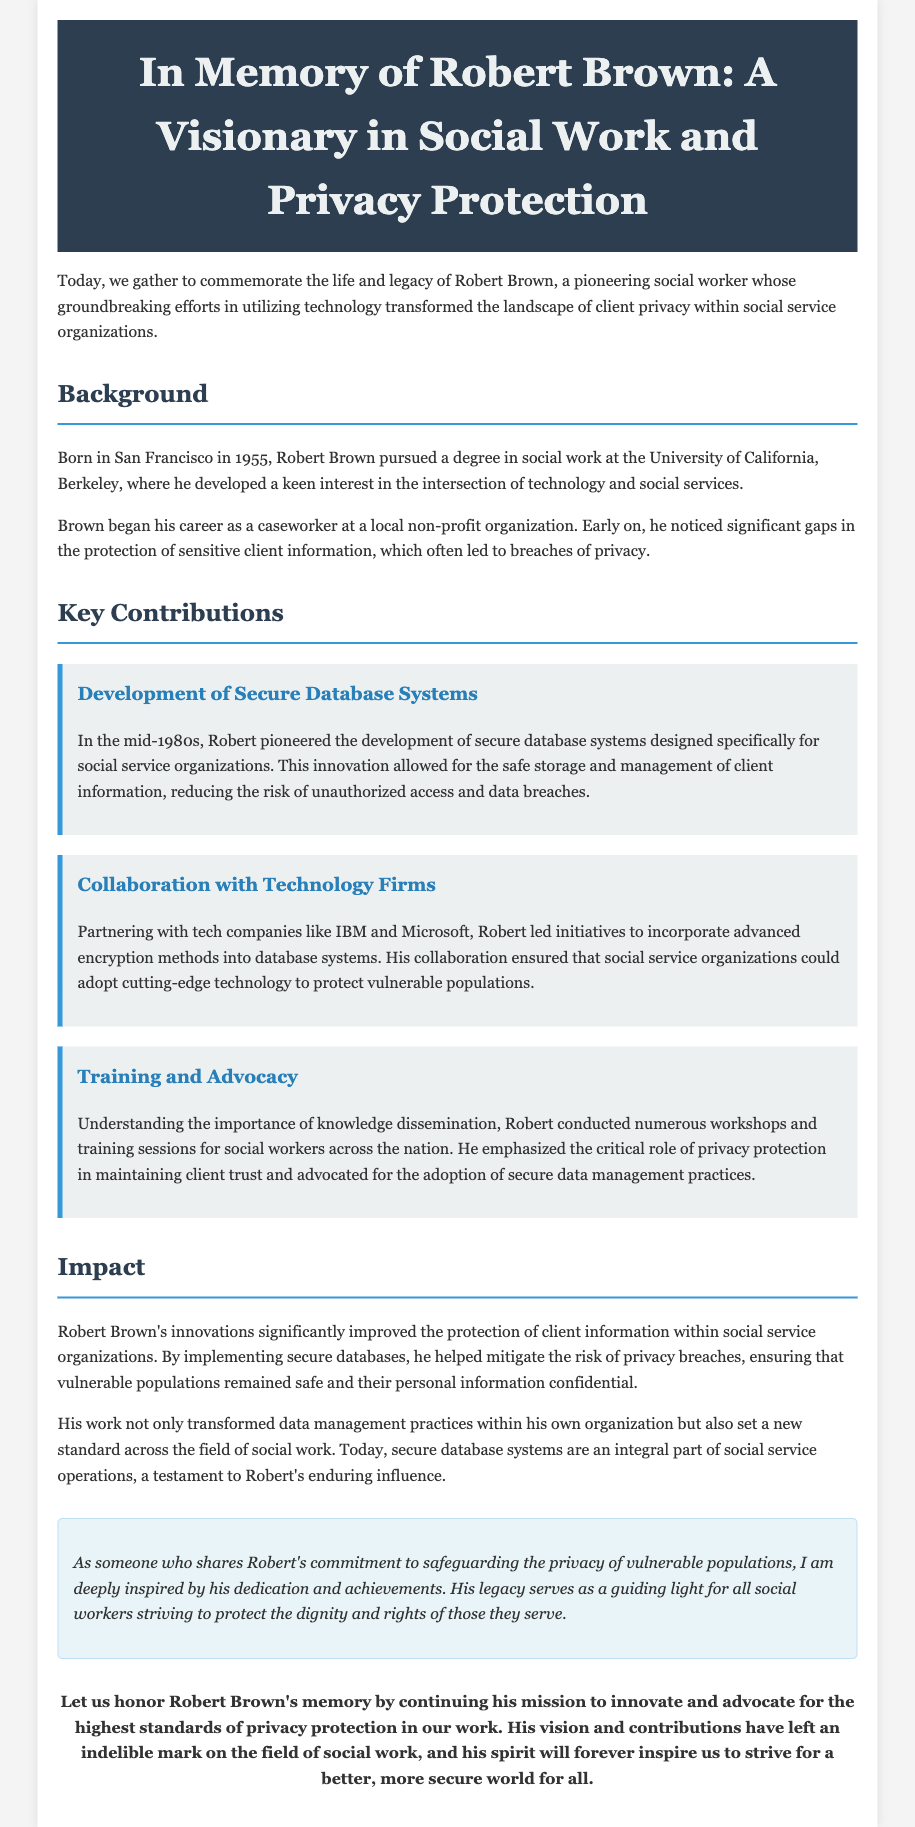What year was Robert Brown born? The document states that Robert Brown was born in 1955.
Answer: 1955 Which university did Robert Brown attend? The document mentions that he pursued a degree in social work at the University of California, Berkeley.
Answer: University of California, Berkeley What did Robert Brown pioneer in the mid-1980s? The document indicates he pioneered the development of secure database systems for social service organizations.
Answer: Secure database systems Who did Robert collaborate with to enhance database security? The document specifies that he partnered with tech companies like IBM and Microsoft.
Answer: IBM and Microsoft What was a significant result of Robert Brown's innovations? The document states that his innovations significantly improved the protection of client information within social service organizations.
Answer: Improved protection of client information In what city was Robert Brown born? The document describes that he was born in San Francisco.
Answer: San Francisco What role did training play in Robert Brown's contributions? The document highlights that he conducted workshops and training sessions for social workers, emphasizing privacy protection.
Answer: Workshops and training sessions What aspect of social work did Robert Brown focus on? The document indicates his focus was on maintaining client privacy within social service organizations.
Answer: Maintaining client privacy What legacy did Robert Brown leave in the field of social work? The document concludes that he set a new standard for privacy protection in social services.
Answer: New standard for privacy protection 